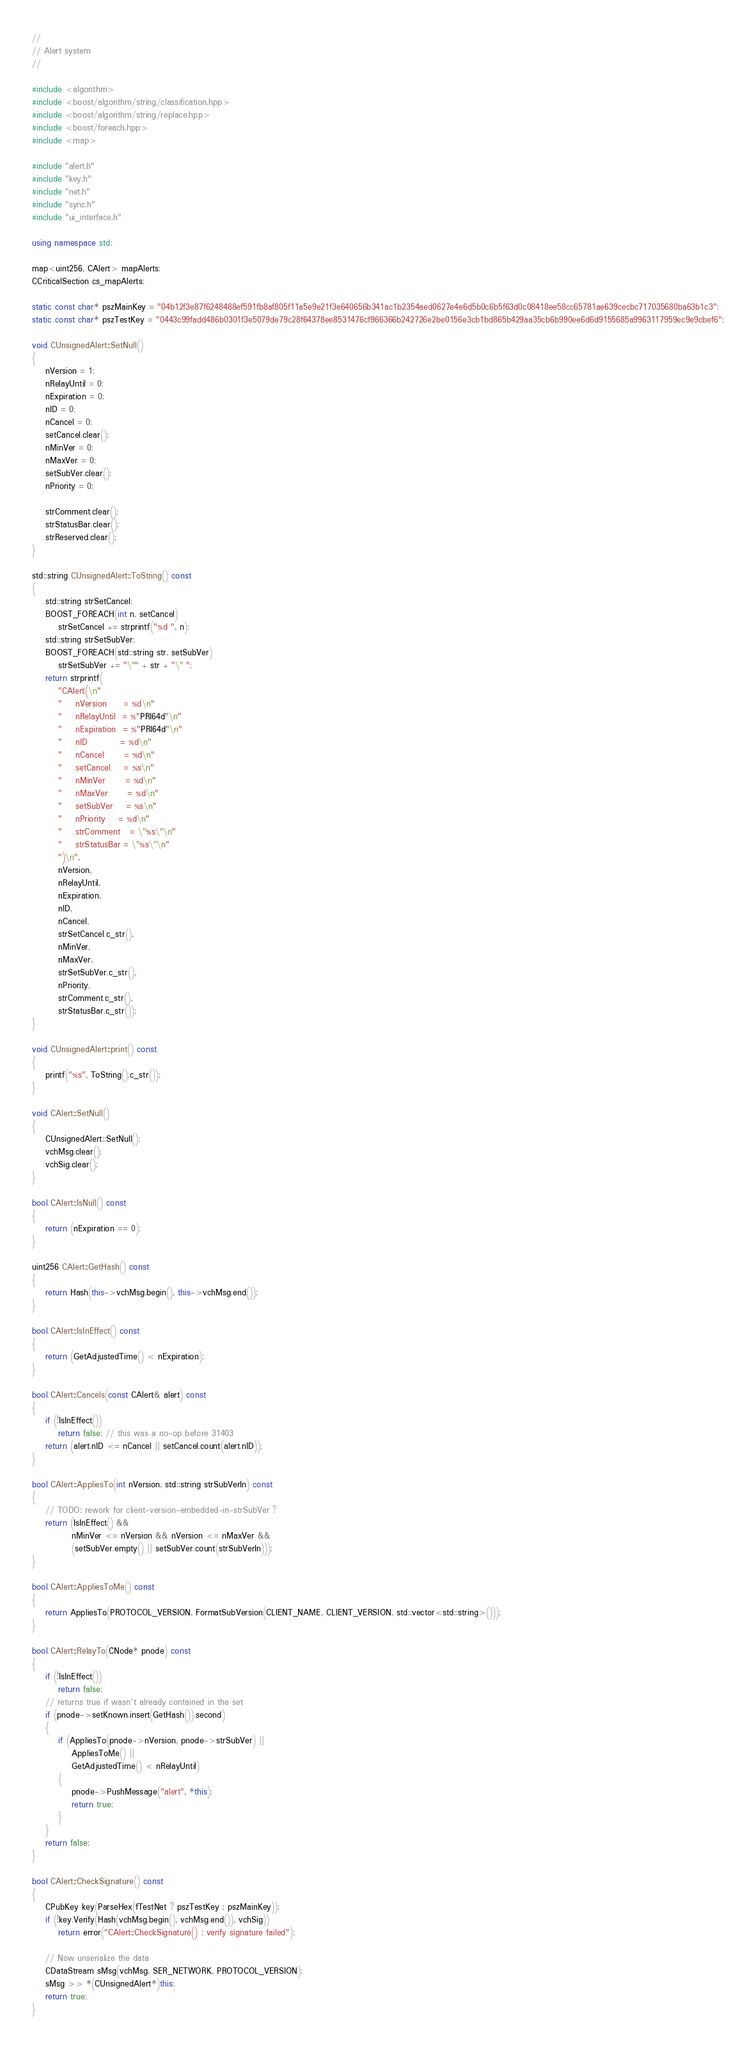Convert code to text. <code><loc_0><loc_0><loc_500><loc_500><_C++_>//
// Alert system
//

#include <algorithm>
#include <boost/algorithm/string/classification.hpp>
#include <boost/algorithm/string/replace.hpp>
#include <boost/foreach.hpp>
#include <map>

#include "alert.h"
#include "key.h"
#include "net.h"
#include "sync.h"
#include "ui_interface.h"

using namespace std;

map<uint256, CAlert> mapAlerts;
CCriticalSection cs_mapAlerts;

static const char* pszMainKey = "04b12f3e87f6248488ef591fb8af805f11a5e9e21f3e640656b341ac1b2354aed0627e4e6d5b0c6b5f63d0c08418ee58cc65781ae639cecbc717035680ba63b1c3";
static const char* pszTestKey = "0443c99fadd486b0301f3e5079de79c28f64378ee8531476cf966366b242726e2be0156e3cb1bd865b429aa35cb6b990ee6d6d9155685a9963117959ec9e9cbef6";

void CUnsignedAlert::SetNull()
{
    nVersion = 1;
    nRelayUntil = 0;
    nExpiration = 0;
    nID = 0;
    nCancel = 0;
    setCancel.clear();
    nMinVer = 0;
    nMaxVer = 0;
    setSubVer.clear();
    nPriority = 0;

    strComment.clear();
    strStatusBar.clear();
    strReserved.clear();
}

std::string CUnsignedAlert::ToString() const
{
    std::string strSetCancel;
    BOOST_FOREACH(int n, setCancel)
        strSetCancel += strprintf("%d ", n);
    std::string strSetSubVer;
    BOOST_FOREACH(std::string str, setSubVer)
        strSetSubVer += "\"" + str + "\" ";
    return strprintf(
        "CAlert(\n"
        "    nVersion     = %d\n"
        "    nRelayUntil  = %"PRI64d"\n"
        "    nExpiration  = %"PRI64d"\n"
        "    nID          = %d\n"
        "    nCancel      = %d\n"
        "    setCancel    = %s\n"
        "    nMinVer      = %d\n"
        "    nMaxVer      = %d\n"
        "    setSubVer    = %s\n"
        "    nPriority    = %d\n"
        "    strComment   = \"%s\"\n"
        "    strStatusBar = \"%s\"\n"
        ")\n",
        nVersion,
        nRelayUntil,
        nExpiration,
        nID,
        nCancel,
        strSetCancel.c_str(),
        nMinVer,
        nMaxVer,
        strSetSubVer.c_str(),
        nPriority,
        strComment.c_str(),
        strStatusBar.c_str());
}

void CUnsignedAlert::print() const
{
    printf("%s", ToString().c_str());
}

void CAlert::SetNull()
{
    CUnsignedAlert::SetNull();
    vchMsg.clear();
    vchSig.clear();
}

bool CAlert::IsNull() const
{
    return (nExpiration == 0);
}

uint256 CAlert::GetHash() const
{
    return Hash(this->vchMsg.begin(), this->vchMsg.end());
}

bool CAlert::IsInEffect() const
{
    return (GetAdjustedTime() < nExpiration);
}

bool CAlert::Cancels(const CAlert& alert) const
{
    if (!IsInEffect())
        return false; // this was a no-op before 31403
    return (alert.nID <= nCancel || setCancel.count(alert.nID));
}

bool CAlert::AppliesTo(int nVersion, std::string strSubVerIn) const
{
    // TODO: rework for client-version-embedded-in-strSubVer ?
    return (IsInEffect() &&
            nMinVer <= nVersion && nVersion <= nMaxVer &&
            (setSubVer.empty() || setSubVer.count(strSubVerIn)));
}

bool CAlert::AppliesToMe() const
{
    return AppliesTo(PROTOCOL_VERSION, FormatSubVersion(CLIENT_NAME, CLIENT_VERSION, std::vector<std::string>()));
}

bool CAlert::RelayTo(CNode* pnode) const
{
    if (!IsInEffect())
        return false;
    // returns true if wasn't already contained in the set
    if (pnode->setKnown.insert(GetHash()).second)
    {
        if (AppliesTo(pnode->nVersion, pnode->strSubVer) ||
            AppliesToMe() ||
            GetAdjustedTime() < nRelayUntil)
        {
            pnode->PushMessage("alert", *this);
            return true;
        }
    }
    return false;
}

bool CAlert::CheckSignature() const
{
    CPubKey key(ParseHex(fTestNet ? pszTestKey : pszMainKey));
    if (!key.Verify(Hash(vchMsg.begin(), vchMsg.end()), vchSig))
        return error("CAlert::CheckSignature() : verify signature failed");

    // Now unserialize the data
    CDataStream sMsg(vchMsg, SER_NETWORK, PROTOCOL_VERSION);
    sMsg >> *(CUnsignedAlert*)this;
    return true;
}
</code> 